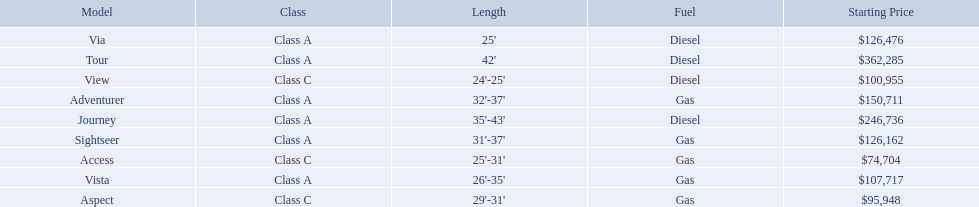What are all of the winnebago models? Tour, Journey, Adventurer, Via, Sightseer, Vista, View, Aspect, Access. What are their prices? $362,285, $246,736, $150,711, $126,476, $126,162, $107,717, $100,955, $95,948, $74,704. And which model costs the most? Tour. What are the prices? $362,285, $246,736, $150,711, $126,476, $126,162, $107,717, $100,955, $95,948, $74,704. What is the top price? $362,285. What model has this price? Tour. 